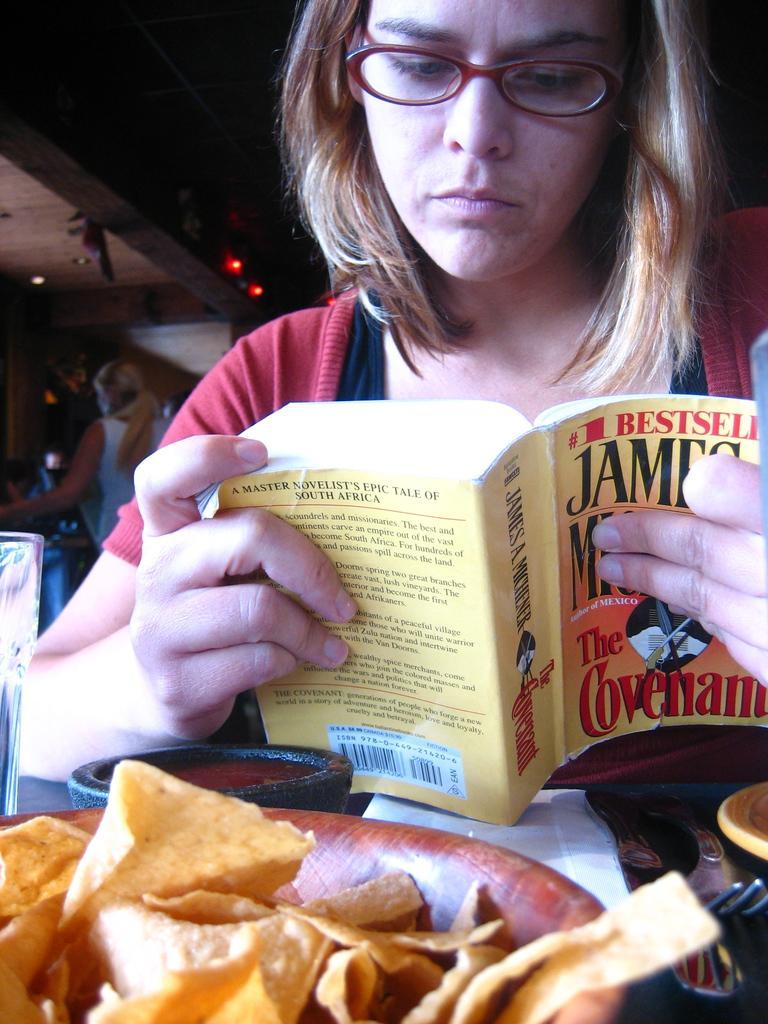Please provide a concise description of this image. In this image we can see a lady holding a book in her hand. In front of her there is a table on which there are food items in bowls. There is a glass. There are other objects on the table. At the top of the image there is a ceiling. 